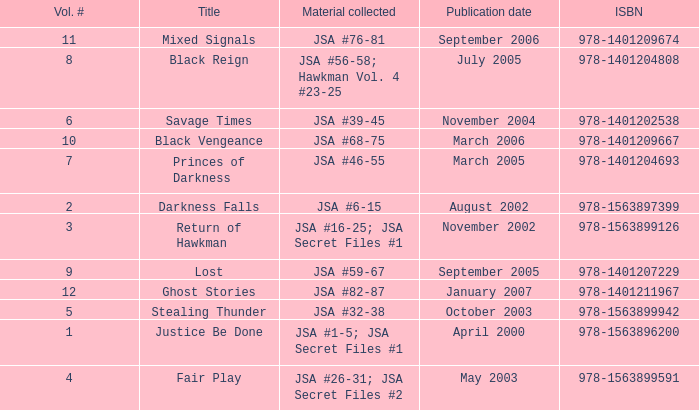How many Volume Numbers have the title of Darkness Falls? 2.0. 